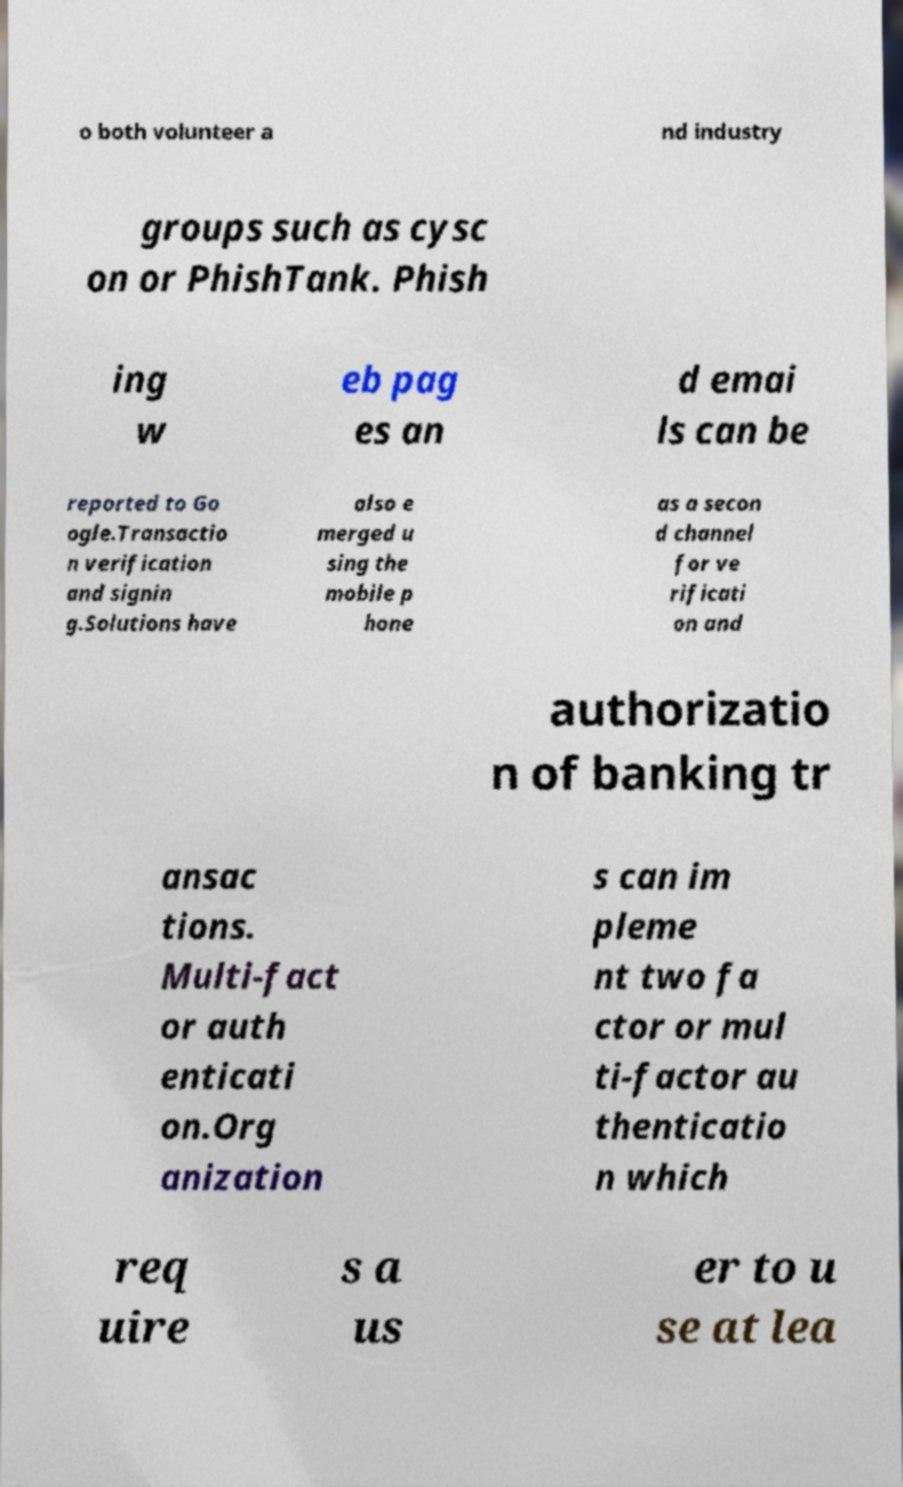Can you accurately transcribe the text from the provided image for me? o both volunteer a nd industry groups such as cysc on or PhishTank. Phish ing w eb pag es an d emai ls can be reported to Go ogle.Transactio n verification and signin g.Solutions have also e merged u sing the mobile p hone as a secon d channel for ve rificati on and authorizatio n of banking tr ansac tions. Multi-fact or auth enticati on.Org anization s can im pleme nt two fa ctor or mul ti-factor au thenticatio n which req uire s a us er to u se at lea 